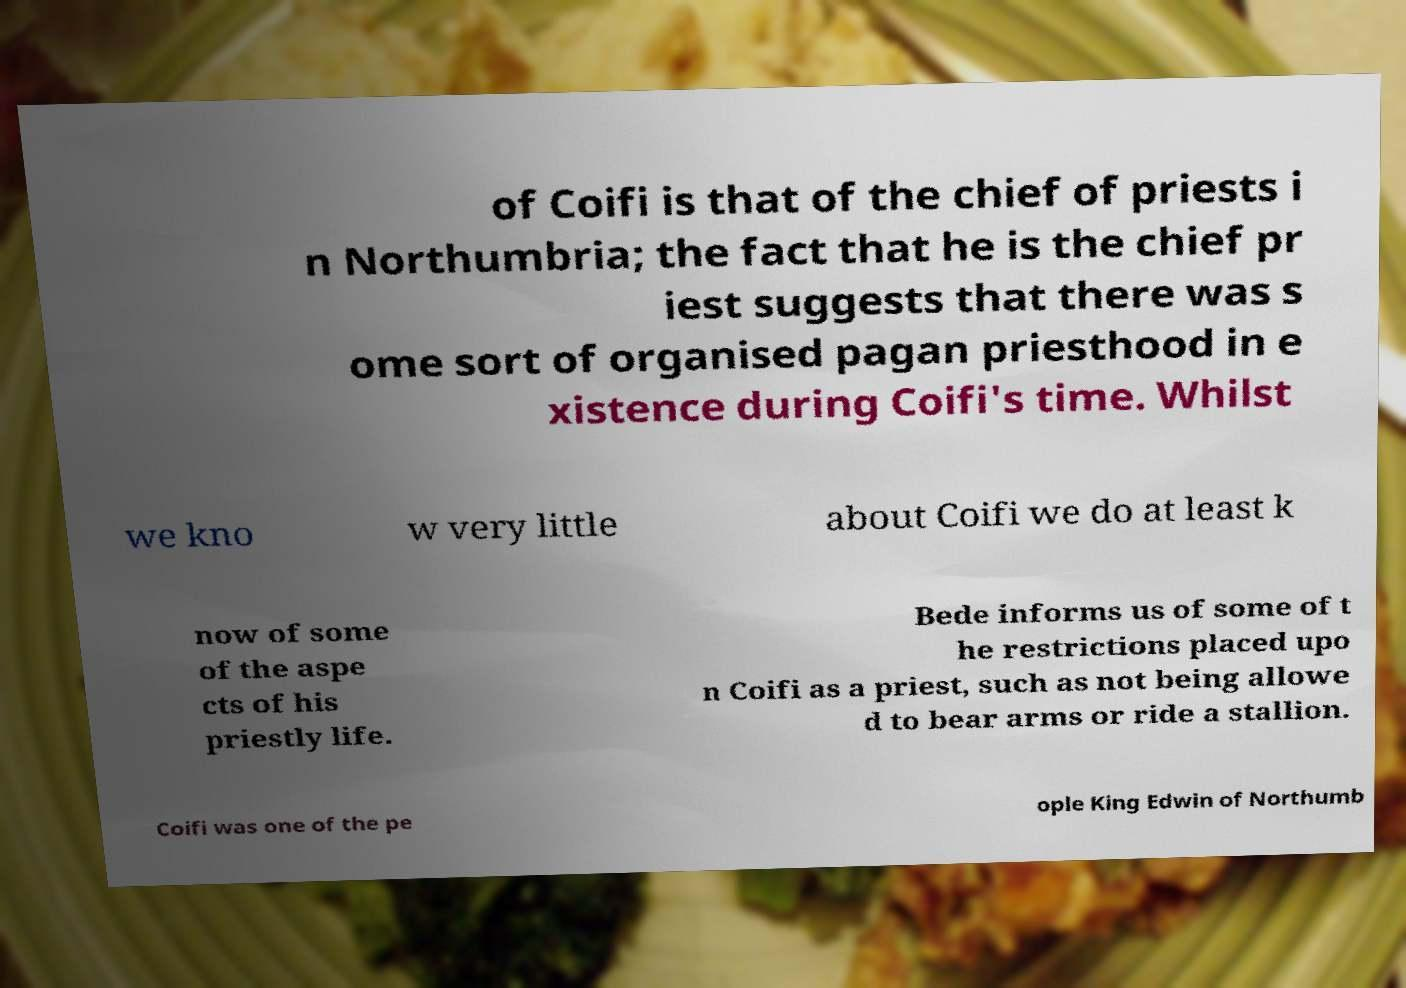Can you accurately transcribe the text from the provided image for me? of Coifi is that of the chief of priests i n Northumbria; the fact that he is the chief pr iest suggests that there was s ome sort of organised pagan priesthood in e xistence during Coifi's time. Whilst we kno w very little about Coifi we do at least k now of some of the aspe cts of his priestly life. Bede informs us of some of t he restrictions placed upo n Coifi as a priest, such as not being allowe d to bear arms or ride a stallion. Coifi was one of the pe ople King Edwin of Northumb 